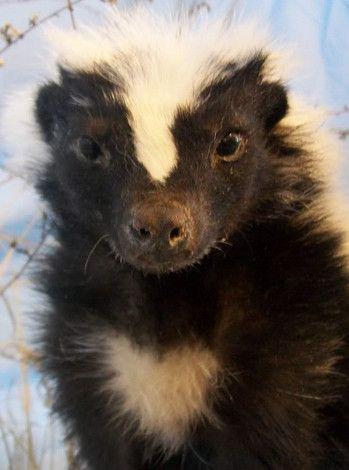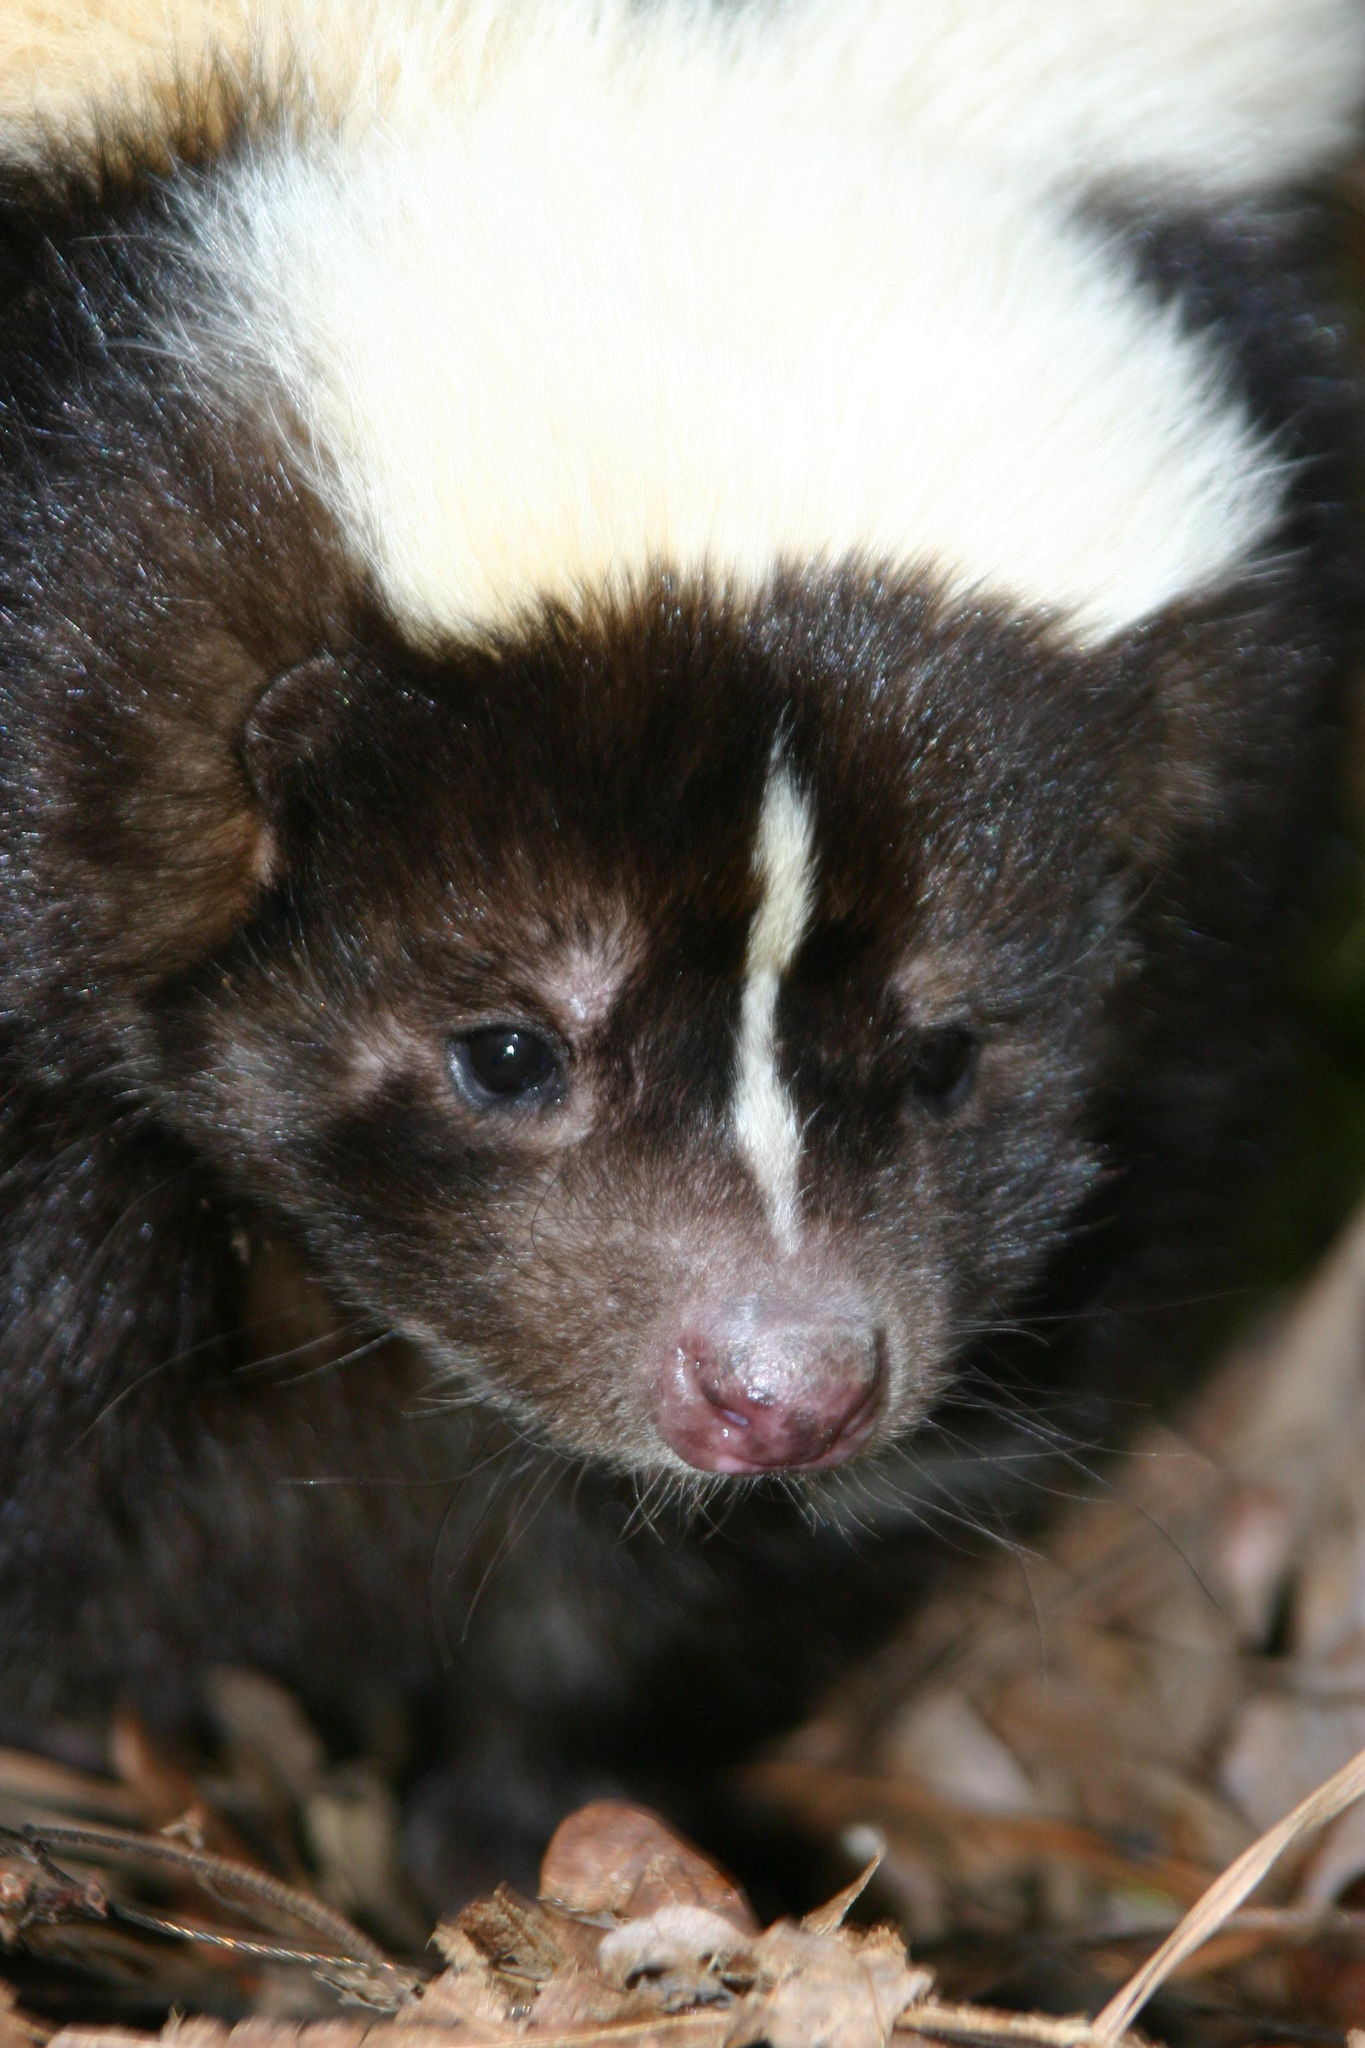The first image is the image on the left, the second image is the image on the right. Given the left and right images, does the statement "The left image features a skunk with a thin white stripe down its rightward-turned head, and the right image features a forward-facing skunk that does not have white fur covering the top of its head." hold true? Answer yes or no. No. The first image is the image on the left, the second image is the image on the right. For the images displayed, is the sentence "Four eyes are visible." factually correct? Answer yes or no. Yes. 